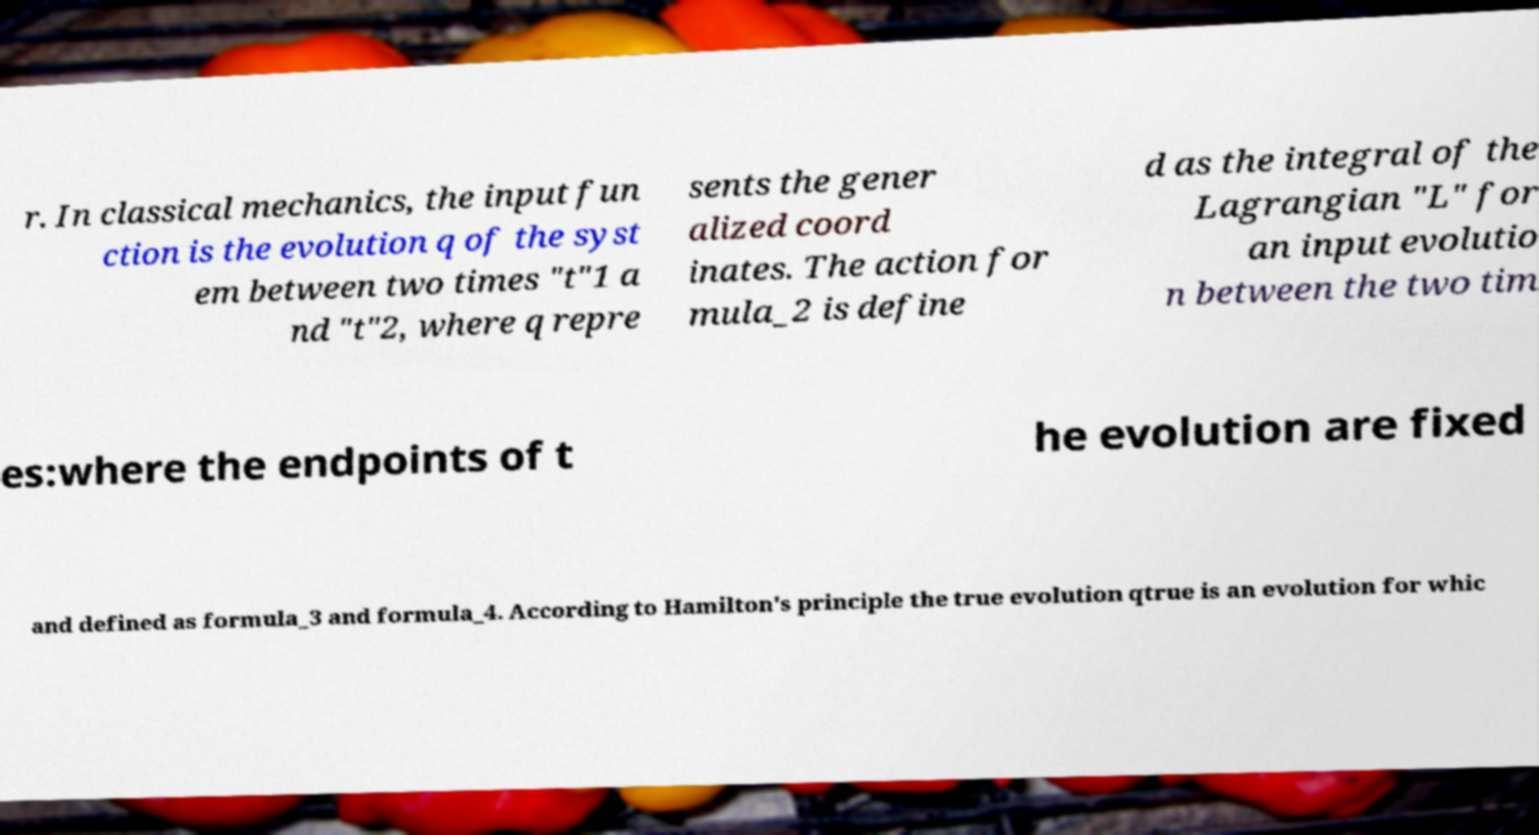For documentation purposes, I need the text within this image transcribed. Could you provide that? r. In classical mechanics, the input fun ction is the evolution q of the syst em between two times "t"1 a nd "t"2, where q repre sents the gener alized coord inates. The action for mula_2 is define d as the integral of the Lagrangian "L" for an input evolutio n between the two tim es:where the endpoints of t he evolution are fixed and defined as formula_3 and formula_4. According to Hamilton's principle the true evolution qtrue is an evolution for whic 